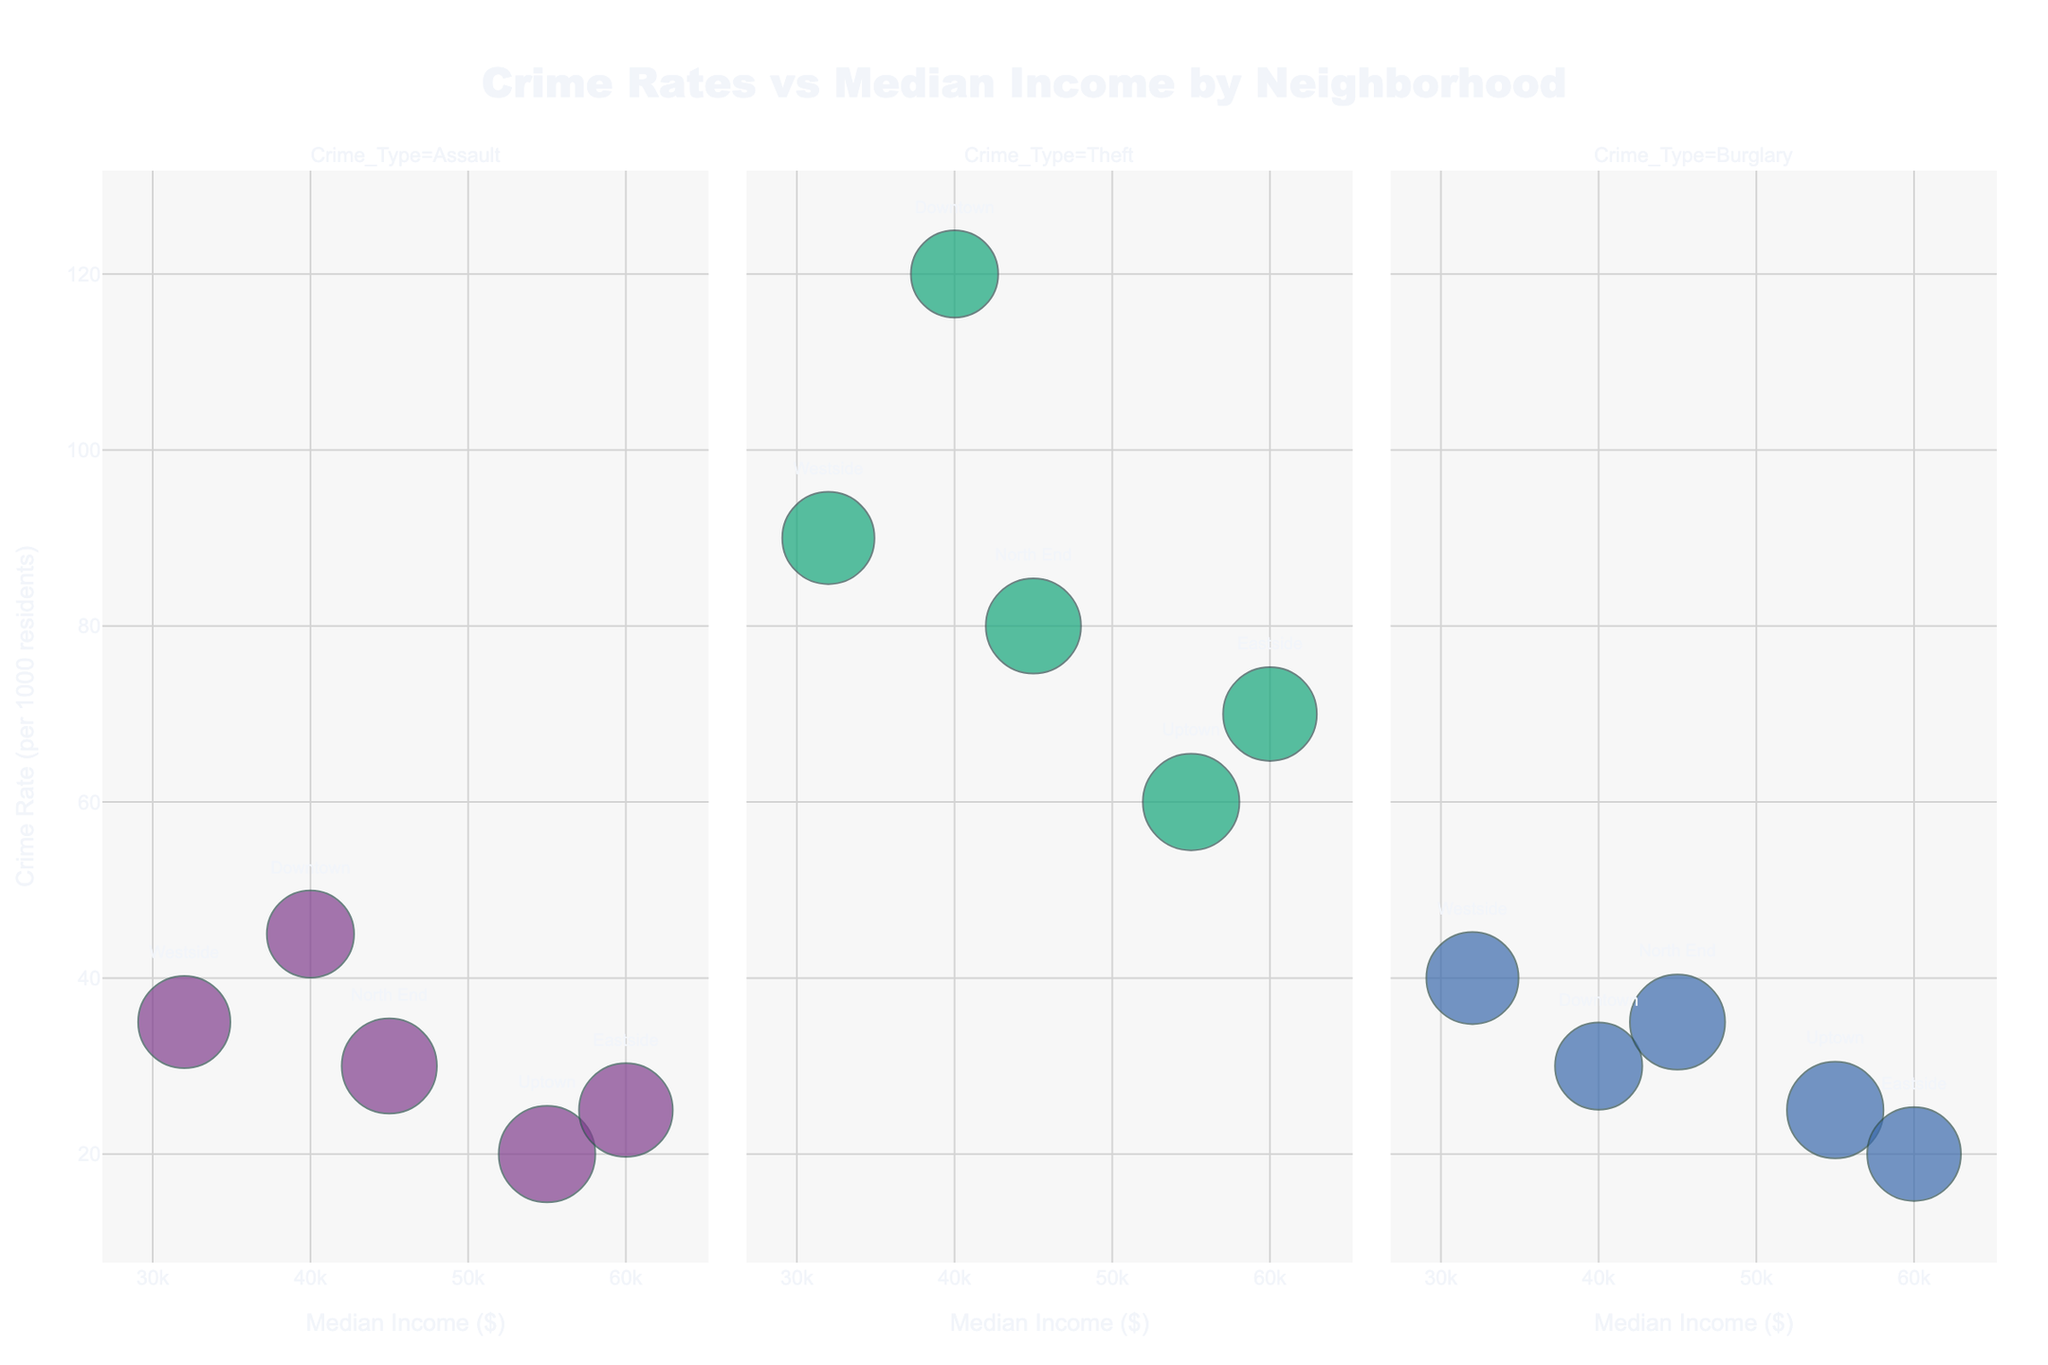What's the title of the figure? The title is typically found at the top of the figure. In this chart, it is clearly displayed in a large font.
Answer: Crime Rates vs Median Income by Neighborhood What are the units for the x-axis and y-axis? The x-axis represents "Median Income" in dollars, and the y-axis represents "Crime Rate" per 1000 residents, as indicated by the labels on the axes.
Answer: Dollars (x-axis), per 1000 residents (y-axis) How many types of crimes are shown in the figure? The figure uses different colors for different crime types and facets them into separate columns. By this categorization, we can see three crime types: Assault, Theft, and Burglary.
Answer: Three Which neighborhood has the highest crime rate for Assault? By checking the y-axis (Crime Rate) for the neighborhood with the highest data point in the Assault category, Downtown shows the highest rate.
Answer: Downtown What is the unemployment rate for North End in the Theft category? By hovering over the bubble representing North End under the Theft category, the unemployment rate is displayed as part of the hover data.
Answer: 6.0% What is the difference in the median income between Uptown and Westside? By finding the coordinates on the x-axis for Uptown and Westside, the median incomes are $55,000 and $32,000, respectively. Subtract the two values: $55,000 - $32,000 = $23,000.
Answer: $23,000 Which neighborhood has the smallest bubble size in the Burglary category? Bubble sizes represent population. The smallest bubble in the Burglary category corresponds to Eastside, indicating the smallest population.
Answer: Eastside Which crime type shows a higher correlation with median income across neighborhoods? By observing the alignment of bubbles in each category with respect to the x-axis, Assault and Theft show noticeable trends, while Burglary shows a more dispersed pattern. Therefore, Theft and Assault might display a higher correlation.
Answer: Theft and Assault Comparing assault crime rates, do higher median income neighborhoods have significantly lower crime rates? Comparing the y-axis (Crime Rate) and x-axis (Median Income) for Crime Type "Assault," higher median incomes like Uptown ($55,000) and Eastside ($60,000) show relatively lower crime rates compared to Downtown ($40,000) and Westside ($32,000).
Answer: Yes 